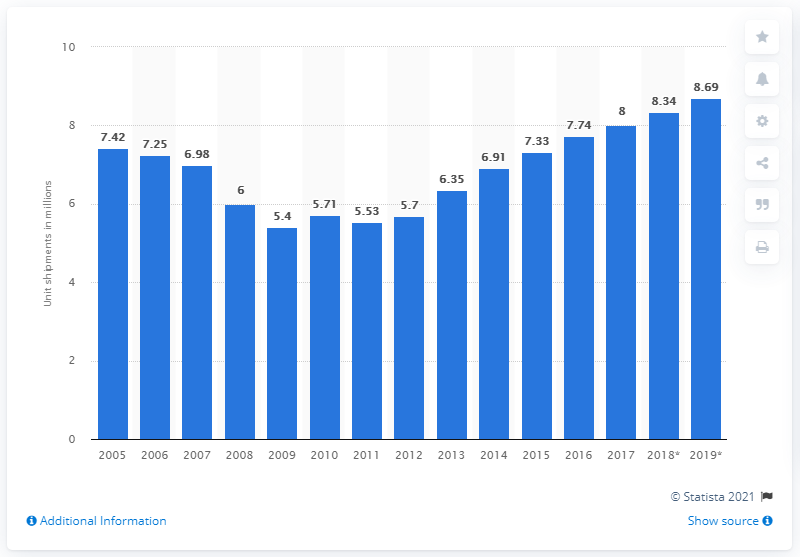Highlight a few significant elements in this photo. In 2017, dishwasher unit shipments in the United States came to an end. In 2018, it is forecasted that 8.34 units of dishwashers will be shipped in the United States. 